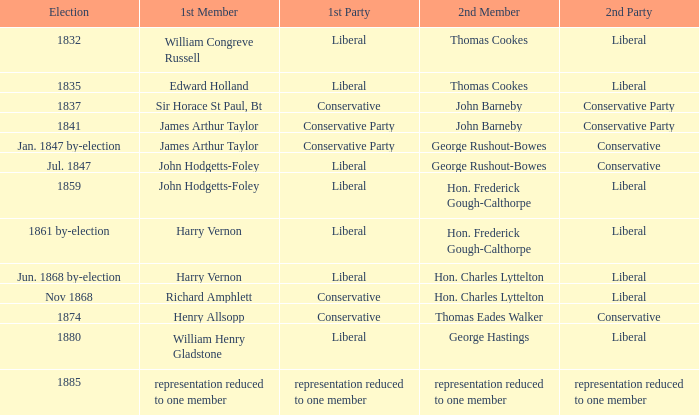What was the 2nd Party when its 2nd Member was George Rushout-Bowes, and the 1st Party was Liberal? Conservative. 